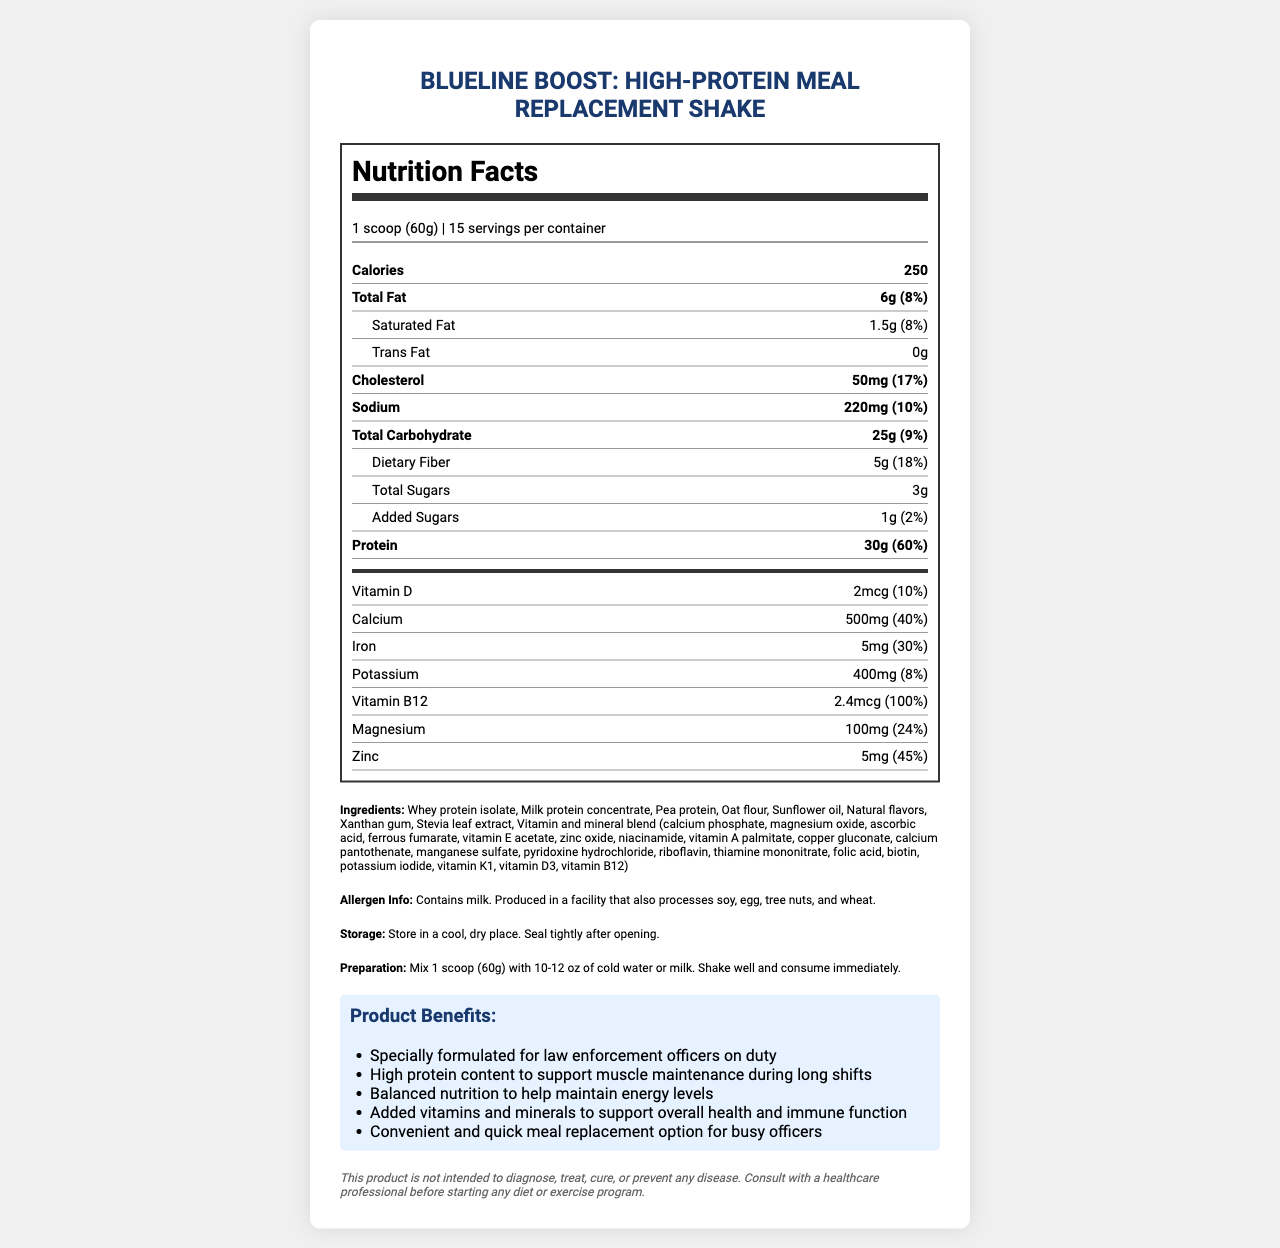what is the product name? The product name is clearly stated at the beginning of the document.
Answer: BlueLine Boost: High-Protein Meal Replacement Shake what is the serving size of the shake? The serving size is mentioned under the serving information section as "1 scoop (60g)".
Answer: 1 scoop (60g) how many calories are in one serving? The number of calories per serving is listed directly under the nutrition facts section.
Answer: 250 what is the amount of protein in each serving? The protein amount per serving is highlighted in the nutrition facts section as "30g".
Answer: 30g what is the preparation instruction for this product? The preparation instructions are outlined clearly in the document.
Answer: Mix 1 scoop (60g) with 10-12 oz of cold water or milk. Shake well and consume immediately. which vitamin has a daily value of 100%? A. Vitamin D B. Vitamin B12 C. Magnesium D. Zinc The daily value percentage for Vitamin B12 is listed as 100% in the document.
Answer: B how much dietary fiber does one serving contain? A. 3g B. 5g C. 25g D. 6g The dietary fiber content is listed as "5g" in the nutrition facts section.
Answer: B does the product contain any added sugars? The added sugars are listed as "1g" in the nutrition facts section.
Answer: Yes is this product suitable for individuals with milk allergies? The allergen information states that the product contains milk.
Answer: No summarize the main benefits of the product. The main benefits are specifically defined under the product benefits section which includes high protein content, balanced nutrition, additional vitamins and minerals, and convenience.
Answer: The shake is specially designed for law enforcement officers on duty, offering high protein content to support muscle maintenance, balanced nutrition for sustained energy, added vitamins and minerals for overall health and immune support, and convenience for a quick meal replacement option. which ingredient is NOT listed in the product? A. Whey protein isolate B. Oat flour C. Almond extract D. Stevia leaf extract The ingredients list does not include almond extract; it includes all other options.
Answer: C what is the main idea of the document? The document comprehensively covers all relevant aspects of the product, including nutrition facts, preparation, and benefits focused on law enforcement officers.
Answer: The document provides detailed nutritional information, ingredients, allergen info, storage and preparation instructions, and the benefits of the BlueLine Boost: High-Protein Meal Replacement Shake, which is formulated for law enforcement officers. how many servings are there per container? The serving information mentions that there are 15 servings per container.
Answer: 15 what is the amount of calcium per serving? The amount of calcium per serving is listed explicitly in the nutrition facts section.
Answer: 500mg does the document specify the price of the product? The document does not provide any information regarding the price of the product.
Answer: Cannot be determined 